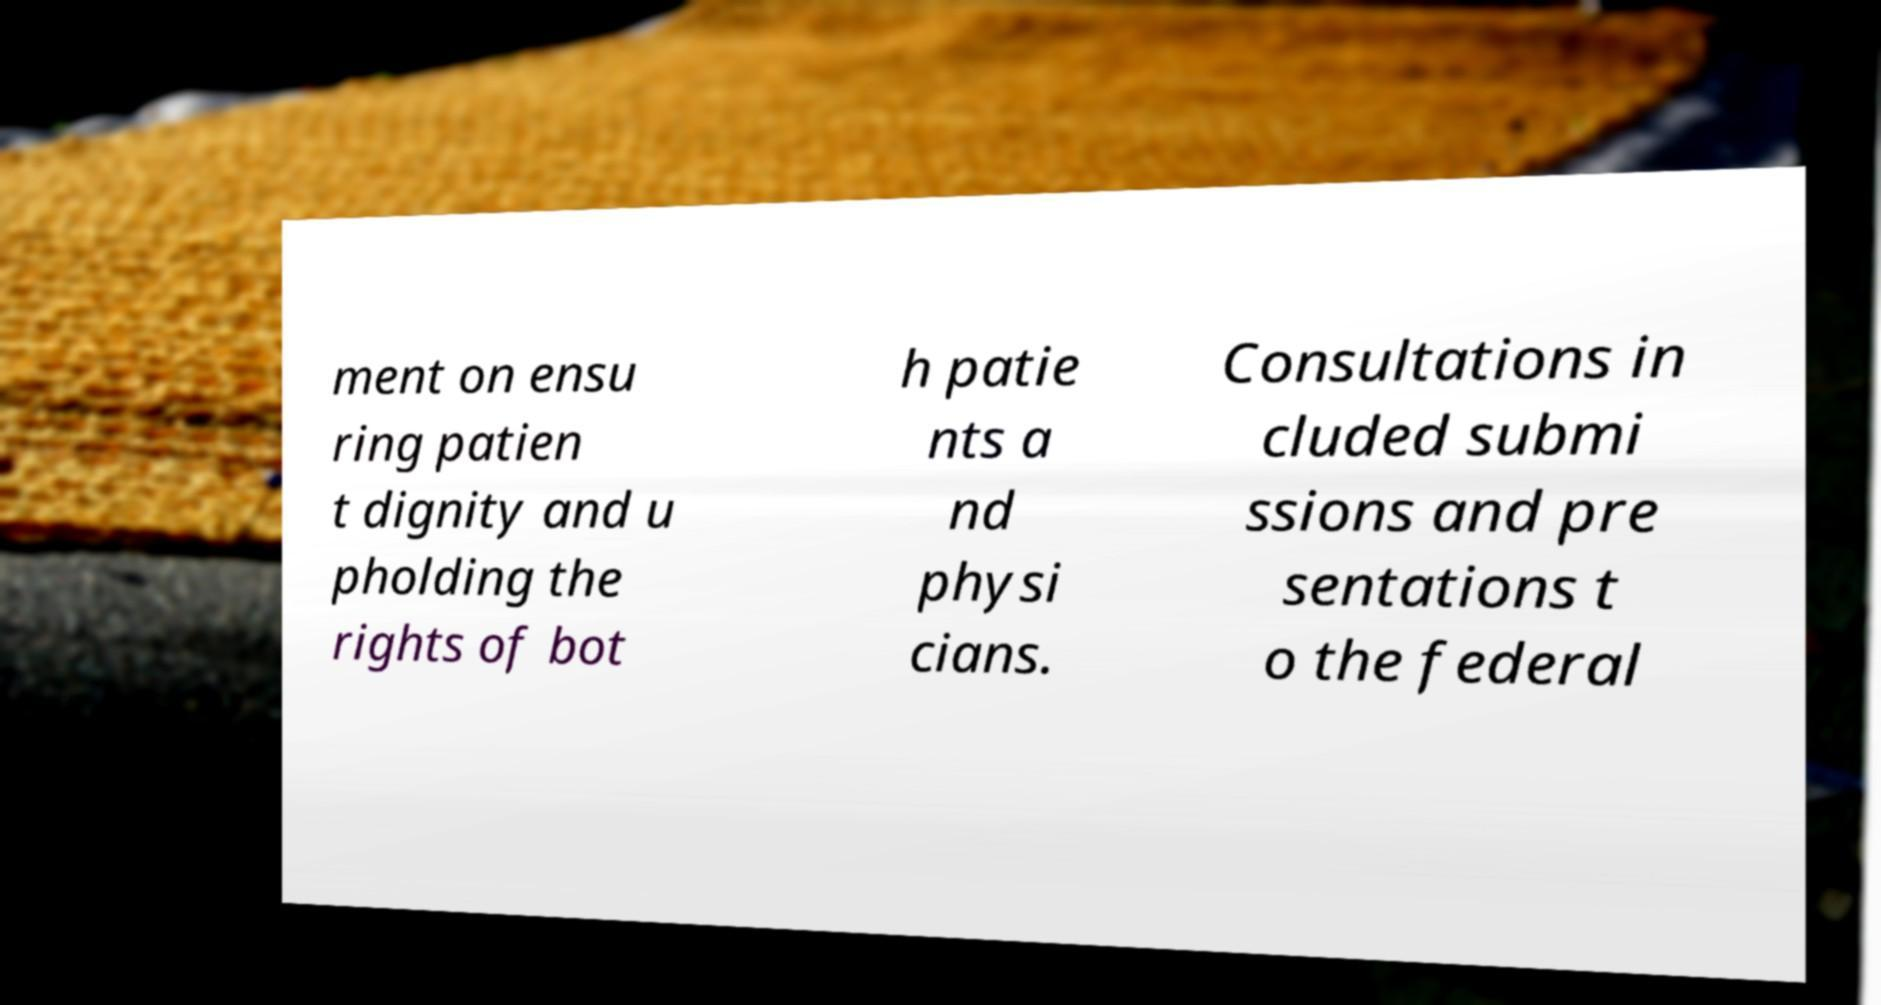Can you read and provide the text displayed in the image?This photo seems to have some interesting text. Can you extract and type it out for me? ment on ensu ring patien t dignity and u pholding the rights of bot h patie nts a nd physi cians. Consultations in cluded submi ssions and pre sentations t o the federal 